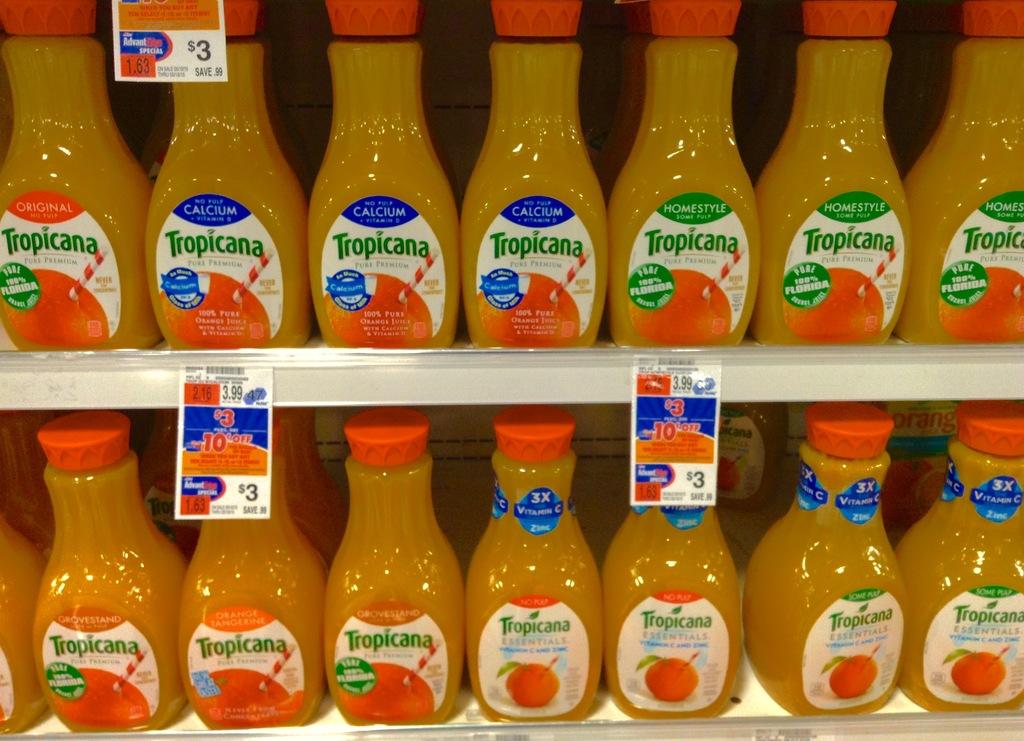What is in the bottles?
Your answer should be very brief. Orange juice. How much is the orange juice?
Offer a very short reply. $3. 